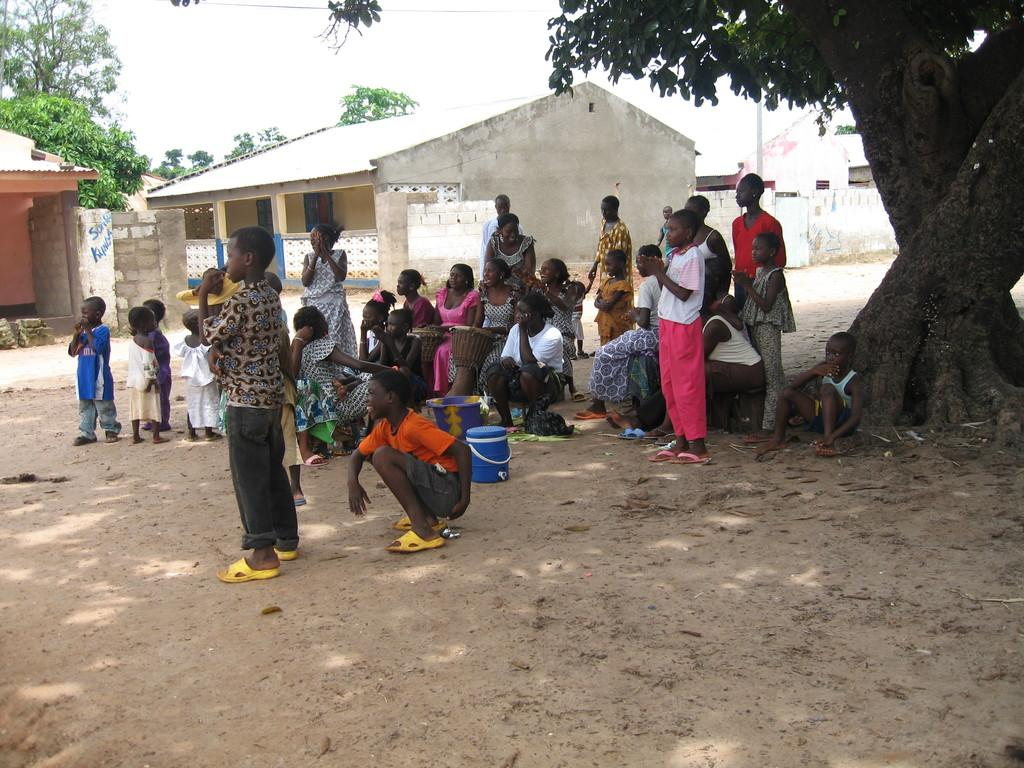How many people are in the image? There is a group of people in the image, but the exact number is not specified. What are the people in the image doing? Some people are sitting, while others are standing. What objects can be seen in the image besides the people? There is a bucket, a can, trees, houses, walls, and pillars in the image. What is visible at the top of the image? The sky is visible at the top of the image. What type of twig is being used for comfort by the people in the image? There is no twig present in the image, and no indication that the people are using any object for comfort. 